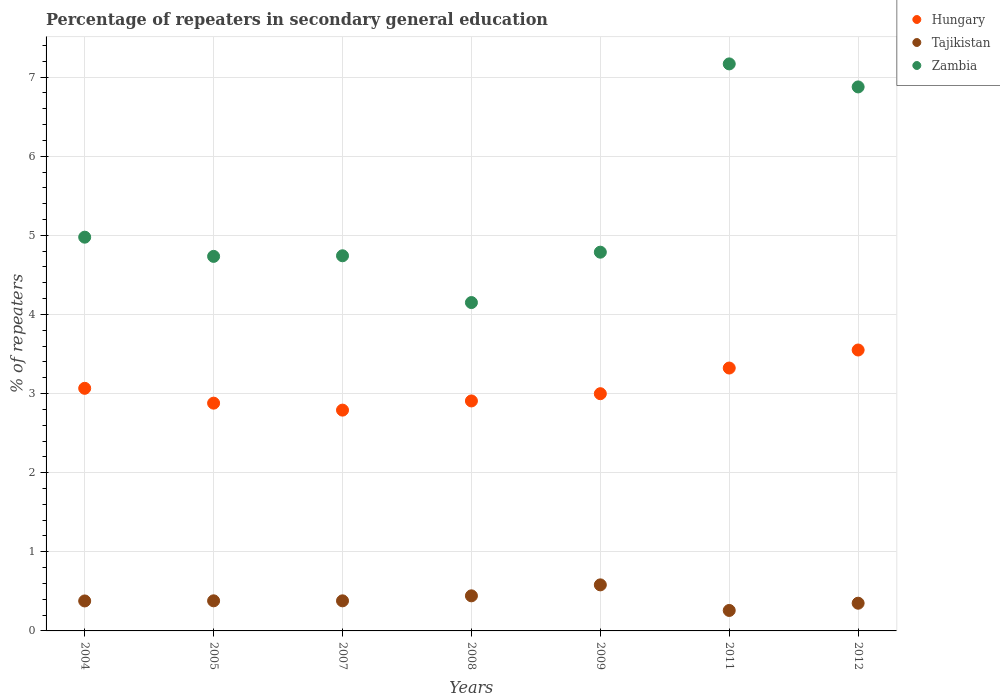How many different coloured dotlines are there?
Make the answer very short. 3. What is the percentage of repeaters in secondary general education in Zambia in 2004?
Your answer should be compact. 4.98. Across all years, what is the maximum percentage of repeaters in secondary general education in Hungary?
Offer a very short reply. 3.55. Across all years, what is the minimum percentage of repeaters in secondary general education in Tajikistan?
Ensure brevity in your answer.  0.26. In which year was the percentage of repeaters in secondary general education in Zambia maximum?
Make the answer very short. 2011. In which year was the percentage of repeaters in secondary general education in Hungary minimum?
Make the answer very short. 2007. What is the total percentage of repeaters in secondary general education in Tajikistan in the graph?
Make the answer very short. 2.77. What is the difference between the percentage of repeaters in secondary general education in Hungary in 2005 and that in 2011?
Make the answer very short. -0.44. What is the difference between the percentage of repeaters in secondary general education in Zambia in 2005 and the percentage of repeaters in secondary general education in Hungary in 2009?
Make the answer very short. 1.74. What is the average percentage of repeaters in secondary general education in Tajikistan per year?
Ensure brevity in your answer.  0.4. In the year 2007, what is the difference between the percentage of repeaters in secondary general education in Tajikistan and percentage of repeaters in secondary general education in Hungary?
Your answer should be very brief. -2.41. In how many years, is the percentage of repeaters in secondary general education in Hungary greater than 3.4 %?
Provide a succinct answer. 1. What is the ratio of the percentage of repeaters in secondary general education in Hungary in 2008 to that in 2009?
Offer a terse response. 0.97. What is the difference between the highest and the second highest percentage of repeaters in secondary general education in Zambia?
Your answer should be compact. 0.29. What is the difference between the highest and the lowest percentage of repeaters in secondary general education in Tajikistan?
Provide a succinct answer. 0.32. In how many years, is the percentage of repeaters in secondary general education in Hungary greater than the average percentage of repeaters in secondary general education in Hungary taken over all years?
Your response must be concise. 2. Does the percentage of repeaters in secondary general education in Zambia monotonically increase over the years?
Your answer should be very brief. No. How many years are there in the graph?
Make the answer very short. 7. How many legend labels are there?
Make the answer very short. 3. How are the legend labels stacked?
Your response must be concise. Vertical. What is the title of the graph?
Give a very brief answer. Percentage of repeaters in secondary general education. What is the label or title of the Y-axis?
Provide a short and direct response. % of repeaters. What is the % of repeaters of Hungary in 2004?
Give a very brief answer. 3.07. What is the % of repeaters in Tajikistan in 2004?
Your response must be concise. 0.38. What is the % of repeaters in Zambia in 2004?
Ensure brevity in your answer.  4.98. What is the % of repeaters of Hungary in 2005?
Offer a very short reply. 2.88. What is the % of repeaters in Tajikistan in 2005?
Give a very brief answer. 0.38. What is the % of repeaters of Zambia in 2005?
Offer a terse response. 4.73. What is the % of repeaters in Hungary in 2007?
Make the answer very short. 2.79. What is the % of repeaters in Tajikistan in 2007?
Give a very brief answer. 0.38. What is the % of repeaters in Zambia in 2007?
Ensure brevity in your answer.  4.74. What is the % of repeaters of Hungary in 2008?
Offer a terse response. 2.91. What is the % of repeaters of Tajikistan in 2008?
Ensure brevity in your answer.  0.44. What is the % of repeaters of Zambia in 2008?
Make the answer very short. 4.15. What is the % of repeaters in Hungary in 2009?
Make the answer very short. 3. What is the % of repeaters in Tajikistan in 2009?
Ensure brevity in your answer.  0.58. What is the % of repeaters of Zambia in 2009?
Provide a short and direct response. 4.79. What is the % of repeaters in Hungary in 2011?
Offer a very short reply. 3.32. What is the % of repeaters of Tajikistan in 2011?
Your response must be concise. 0.26. What is the % of repeaters in Zambia in 2011?
Keep it short and to the point. 7.17. What is the % of repeaters of Hungary in 2012?
Ensure brevity in your answer.  3.55. What is the % of repeaters of Tajikistan in 2012?
Make the answer very short. 0.35. What is the % of repeaters of Zambia in 2012?
Make the answer very short. 6.88. Across all years, what is the maximum % of repeaters in Hungary?
Offer a very short reply. 3.55. Across all years, what is the maximum % of repeaters of Tajikistan?
Provide a succinct answer. 0.58. Across all years, what is the maximum % of repeaters of Zambia?
Your response must be concise. 7.17. Across all years, what is the minimum % of repeaters of Hungary?
Make the answer very short. 2.79. Across all years, what is the minimum % of repeaters in Tajikistan?
Keep it short and to the point. 0.26. Across all years, what is the minimum % of repeaters of Zambia?
Your answer should be very brief. 4.15. What is the total % of repeaters in Hungary in the graph?
Your response must be concise. 21.51. What is the total % of repeaters of Tajikistan in the graph?
Provide a succinct answer. 2.77. What is the total % of repeaters in Zambia in the graph?
Your response must be concise. 37.43. What is the difference between the % of repeaters in Hungary in 2004 and that in 2005?
Offer a terse response. 0.19. What is the difference between the % of repeaters in Tajikistan in 2004 and that in 2005?
Your answer should be very brief. -0. What is the difference between the % of repeaters in Zambia in 2004 and that in 2005?
Make the answer very short. 0.24. What is the difference between the % of repeaters in Hungary in 2004 and that in 2007?
Keep it short and to the point. 0.28. What is the difference between the % of repeaters of Tajikistan in 2004 and that in 2007?
Your answer should be compact. -0. What is the difference between the % of repeaters in Zambia in 2004 and that in 2007?
Give a very brief answer. 0.24. What is the difference between the % of repeaters of Hungary in 2004 and that in 2008?
Provide a short and direct response. 0.16. What is the difference between the % of repeaters in Tajikistan in 2004 and that in 2008?
Offer a terse response. -0.06. What is the difference between the % of repeaters of Zambia in 2004 and that in 2008?
Ensure brevity in your answer.  0.83. What is the difference between the % of repeaters in Hungary in 2004 and that in 2009?
Ensure brevity in your answer.  0.07. What is the difference between the % of repeaters of Tajikistan in 2004 and that in 2009?
Offer a very short reply. -0.2. What is the difference between the % of repeaters in Zambia in 2004 and that in 2009?
Give a very brief answer. 0.19. What is the difference between the % of repeaters of Hungary in 2004 and that in 2011?
Ensure brevity in your answer.  -0.26. What is the difference between the % of repeaters of Tajikistan in 2004 and that in 2011?
Provide a succinct answer. 0.12. What is the difference between the % of repeaters of Zambia in 2004 and that in 2011?
Your answer should be very brief. -2.19. What is the difference between the % of repeaters of Hungary in 2004 and that in 2012?
Give a very brief answer. -0.48. What is the difference between the % of repeaters in Tajikistan in 2004 and that in 2012?
Give a very brief answer. 0.03. What is the difference between the % of repeaters of Zambia in 2004 and that in 2012?
Give a very brief answer. -1.9. What is the difference between the % of repeaters of Hungary in 2005 and that in 2007?
Provide a short and direct response. 0.09. What is the difference between the % of repeaters in Zambia in 2005 and that in 2007?
Offer a very short reply. -0.01. What is the difference between the % of repeaters in Hungary in 2005 and that in 2008?
Keep it short and to the point. -0.03. What is the difference between the % of repeaters in Tajikistan in 2005 and that in 2008?
Your answer should be very brief. -0.06. What is the difference between the % of repeaters of Zambia in 2005 and that in 2008?
Provide a short and direct response. 0.58. What is the difference between the % of repeaters of Hungary in 2005 and that in 2009?
Your response must be concise. -0.12. What is the difference between the % of repeaters of Tajikistan in 2005 and that in 2009?
Give a very brief answer. -0.2. What is the difference between the % of repeaters of Zambia in 2005 and that in 2009?
Your answer should be compact. -0.05. What is the difference between the % of repeaters of Hungary in 2005 and that in 2011?
Ensure brevity in your answer.  -0.44. What is the difference between the % of repeaters of Tajikistan in 2005 and that in 2011?
Give a very brief answer. 0.12. What is the difference between the % of repeaters of Zambia in 2005 and that in 2011?
Keep it short and to the point. -2.43. What is the difference between the % of repeaters in Hungary in 2005 and that in 2012?
Offer a terse response. -0.67. What is the difference between the % of repeaters in Tajikistan in 2005 and that in 2012?
Give a very brief answer. 0.03. What is the difference between the % of repeaters of Zambia in 2005 and that in 2012?
Make the answer very short. -2.14. What is the difference between the % of repeaters in Hungary in 2007 and that in 2008?
Provide a short and direct response. -0.12. What is the difference between the % of repeaters in Tajikistan in 2007 and that in 2008?
Keep it short and to the point. -0.06. What is the difference between the % of repeaters in Zambia in 2007 and that in 2008?
Ensure brevity in your answer.  0.59. What is the difference between the % of repeaters in Hungary in 2007 and that in 2009?
Your answer should be very brief. -0.21. What is the difference between the % of repeaters of Tajikistan in 2007 and that in 2009?
Your answer should be very brief. -0.2. What is the difference between the % of repeaters of Zambia in 2007 and that in 2009?
Ensure brevity in your answer.  -0.05. What is the difference between the % of repeaters in Hungary in 2007 and that in 2011?
Offer a terse response. -0.53. What is the difference between the % of repeaters of Tajikistan in 2007 and that in 2011?
Give a very brief answer. 0.12. What is the difference between the % of repeaters in Zambia in 2007 and that in 2011?
Give a very brief answer. -2.43. What is the difference between the % of repeaters in Hungary in 2007 and that in 2012?
Your response must be concise. -0.76. What is the difference between the % of repeaters in Zambia in 2007 and that in 2012?
Your answer should be very brief. -2.13. What is the difference between the % of repeaters of Hungary in 2008 and that in 2009?
Provide a short and direct response. -0.09. What is the difference between the % of repeaters of Tajikistan in 2008 and that in 2009?
Give a very brief answer. -0.14. What is the difference between the % of repeaters in Zambia in 2008 and that in 2009?
Make the answer very short. -0.64. What is the difference between the % of repeaters in Hungary in 2008 and that in 2011?
Keep it short and to the point. -0.42. What is the difference between the % of repeaters in Tajikistan in 2008 and that in 2011?
Give a very brief answer. 0.18. What is the difference between the % of repeaters of Zambia in 2008 and that in 2011?
Keep it short and to the point. -3.02. What is the difference between the % of repeaters of Hungary in 2008 and that in 2012?
Keep it short and to the point. -0.64. What is the difference between the % of repeaters in Tajikistan in 2008 and that in 2012?
Offer a terse response. 0.09. What is the difference between the % of repeaters of Zambia in 2008 and that in 2012?
Keep it short and to the point. -2.73. What is the difference between the % of repeaters of Hungary in 2009 and that in 2011?
Offer a terse response. -0.32. What is the difference between the % of repeaters in Tajikistan in 2009 and that in 2011?
Provide a succinct answer. 0.32. What is the difference between the % of repeaters of Zambia in 2009 and that in 2011?
Your answer should be very brief. -2.38. What is the difference between the % of repeaters in Hungary in 2009 and that in 2012?
Ensure brevity in your answer.  -0.55. What is the difference between the % of repeaters in Tajikistan in 2009 and that in 2012?
Your answer should be compact. 0.23. What is the difference between the % of repeaters in Zambia in 2009 and that in 2012?
Offer a very short reply. -2.09. What is the difference between the % of repeaters of Hungary in 2011 and that in 2012?
Provide a short and direct response. -0.23. What is the difference between the % of repeaters in Tajikistan in 2011 and that in 2012?
Ensure brevity in your answer.  -0.09. What is the difference between the % of repeaters of Zambia in 2011 and that in 2012?
Your answer should be compact. 0.29. What is the difference between the % of repeaters in Hungary in 2004 and the % of repeaters in Tajikistan in 2005?
Your answer should be very brief. 2.69. What is the difference between the % of repeaters of Hungary in 2004 and the % of repeaters of Zambia in 2005?
Your response must be concise. -1.67. What is the difference between the % of repeaters in Tajikistan in 2004 and the % of repeaters in Zambia in 2005?
Your response must be concise. -4.35. What is the difference between the % of repeaters of Hungary in 2004 and the % of repeaters of Tajikistan in 2007?
Give a very brief answer. 2.69. What is the difference between the % of repeaters of Hungary in 2004 and the % of repeaters of Zambia in 2007?
Your answer should be very brief. -1.68. What is the difference between the % of repeaters in Tajikistan in 2004 and the % of repeaters in Zambia in 2007?
Ensure brevity in your answer.  -4.36. What is the difference between the % of repeaters in Hungary in 2004 and the % of repeaters in Tajikistan in 2008?
Your answer should be very brief. 2.62. What is the difference between the % of repeaters of Hungary in 2004 and the % of repeaters of Zambia in 2008?
Offer a very short reply. -1.08. What is the difference between the % of repeaters in Tajikistan in 2004 and the % of repeaters in Zambia in 2008?
Your answer should be very brief. -3.77. What is the difference between the % of repeaters in Hungary in 2004 and the % of repeaters in Tajikistan in 2009?
Your answer should be compact. 2.48. What is the difference between the % of repeaters in Hungary in 2004 and the % of repeaters in Zambia in 2009?
Provide a short and direct response. -1.72. What is the difference between the % of repeaters of Tajikistan in 2004 and the % of repeaters of Zambia in 2009?
Your answer should be very brief. -4.41. What is the difference between the % of repeaters of Hungary in 2004 and the % of repeaters of Tajikistan in 2011?
Your answer should be very brief. 2.81. What is the difference between the % of repeaters of Hungary in 2004 and the % of repeaters of Zambia in 2011?
Your answer should be very brief. -4.1. What is the difference between the % of repeaters in Tajikistan in 2004 and the % of repeaters in Zambia in 2011?
Offer a terse response. -6.79. What is the difference between the % of repeaters in Hungary in 2004 and the % of repeaters in Tajikistan in 2012?
Your answer should be compact. 2.72. What is the difference between the % of repeaters of Hungary in 2004 and the % of repeaters of Zambia in 2012?
Your answer should be very brief. -3.81. What is the difference between the % of repeaters of Tajikistan in 2004 and the % of repeaters of Zambia in 2012?
Make the answer very short. -6.5. What is the difference between the % of repeaters in Hungary in 2005 and the % of repeaters in Tajikistan in 2007?
Provide a short and direct response. 2.5. What is the difference between the % of repeaters of Hungary in 2005 and the % of repeaters of Zambia in 2007?
Provide a succinct answer. -1.86. What is the difference between the % of repeaters of Tajikistan in 2005 and the % of repeaters of Zambia in 2007?
Your response must be concise. -4.36. What is the difference between the % of repeaters of Hungary in 2005 and the % of repeaters of Tajikistan in 2008?
Ensure brevity in your answer.  2.44. What is the difference between the % of repeaters of Hungary in 2005 and the % of repeaters of Zambia in 2008?
Provide a short and direct response. -1.27. What is the difference between the % of repeaters in Tajikistan in 2005 and the % of repeaters in Zambia in 2008?
Give a very brief answer. -3.77. What is the difference between the % of repeaters of Hungary in 2005 and the % of repeaters of Tajikistan in 2009?
Your response must be concise. 2.3. What is the difference between the % of repeaters in Hungary in 2005 and the % of repeaters in Zambia in 2009?
Your response must be concise. -1.91. What is the difference between the % of repeaters in Tajikistan in 2005 and the % of repeaters in Zambia in 2009?
Keep it short and to the point. -4.41. What is the difference between the % of repeaters of Hungary in 2005 and the % of repeaters of Tajikistan in 2011?
Your answer should be compact. 2.62. What is the difference between the % of repeaters in Hungary in 2005 and the % of repeaters in Zambia in 2011?
Your answer should be compact. -4.29. What is the difference between the % of repeaters in Tajikistan in 2005 and the % of repeaters in Zambia in 2011?
Make the answer very short. -6.79. What is the difference between the % of repeaters in Hungary in 2005 and the % of repeaters in Tajikistan in 2012?
Your answer should be very brief. 2.53. What is the difference between the % of repeaters in Hungary in 2005 and the % of repeaters in Zambia in 2012?
Keep it short and to the point. -4. What is the difference between the % of repeaters of Tajikistan in 2005 and the % of repeaters of Zambia in 2012?
Your response must be concise. -6.5. What is the difference between the % of repeaters in Hungary in 2007 and the % of repeaters in Tajikistan in 2008?
Offer a terse response. 2.35. What is the difference between the % of repeaters in Hungary in 2007 and the % of repeaters in Zambia in 2008?
Your response must be concise. -1.36. What is the difference between the % of repeaters of Tajikistan in 2007 and the % of repeaters of Zambia in 2008?
Provide a succinct answer. -3.77. What is the difference between the % of repeaters of Hungary in 2007 and the % of repeaters of Tajikistan in 2009?
Your answer should be very brief. 2.21. What is the difference between the % of repeaters of Hungary in 2007 and the % of repeaters of Zambia in 2009?
Your response must be concise. -2. What is the difference between the % of repeaters of Tajikistan in 2007 and the % of repeaters of Zambia in 2009?
Keep it short and to the point. -4.41. What is the difference between the % of repeaters of Hungary in 2007 and the % of repeaters of Tajikistan in 2011?
Offer a very short reply. 2.53. What is the difference between the % of repeaters of Hungary in 2007 and the % of repeaters of Zambia in 2011?
Make the answer very short. -4.38. What is the difference between the % of repeaters in Tajikistan in 2007 and the % of repeaters in Zambia in 2011?
Provide a succinct answer. -6.79. What is the difference between the % of repeaters in Hungary in 2007 and the % of repeaters in Tajikistan in 2012?
Offer a terse response. 2.44. What is the difference between the % of repeaters of Hungary in 2007 and the % of repeaters of Zambia in 2012?
Ensure brevity in your answer.  -4.08. What is the difference between the % of repeaters in Tajikistan in 2007 and the % of repeaters in Zambia in 2012?
Your response must be concise. -6.5. What is the difference between the % of repeaters in Hungary in 2008 and the % of repeaters in Tajikistan in 2009?
Keep it short and to the point. 2.32. What is the difference between the % of repeaters in Hungary in 2008 and the % of repeaters in Zambia in 2009?
Give a very brief answer. -1.88. What is the difference between the % of repeaters in Tajikistan in 2008 and the % of repeaters in Zambia in 2009?
Give a very brief answer. -4.34. What is the difference between the % of repeaters of Hungary in 2008 and the % of repeaters of Tajikistan in 2011?
Offer a terse response. 2.65. What is the difference between the % of repeaters of Hungary in 2008 and the % of repeaters of Zambia in 2011?
Offer a terse response. -4.26. What is the difference between the % of repeaters in Tajikistan in 2008 and the % of repeaters in Zambia in 2011?
Provide a succinct answer. -6.72. What is the difference between the % of repeaters in Hungary in 2008 and the % of repeaters in Tajikistan in 2012?
Give a very brief answer. 2.56. What is the difference between the % of repeaters of Hungary in 2008 and the % of repeaters of Zambia in 2012?
Your answer should be very brief. -3.97. What is the difference between the % of repeaters in Tajikistan in 2008 and the % of repeaters in Zambia in 2012?
Your response must be concise. -6.43. What is the difference between the % of repeaters in Hungary in 2009 and the % of repeaters in Tajikistan in 2011?
Make the answer very short. 2.74. What is the difference between the % of repeaters in Hungary in 2009 and the % of repeaters in Zambia in 2011?
Make the answer very short. -4.17. What is the difference between the % of repeaters in Tajikistan in 2009 and the % of repeaters in Zambia in 2011?
Provide a short and direct response. -6.58. What is the difference between the % of repeaters of Hungary in 2009 and the % of repeaters of Tajikistan in 2012?
Your answer should be very brief. 2.65. What is the difference between the % of repeaters of Hungary in 2009 and the % of repeaters of Zambia in 2012?
Make the answer very short. -3.88. What is the difference between the % of repeaters in Tajikistan in 2009 and the % of repeaters in Zambia in 2012?
Give a very brief answer. -6.29. What is the difference between the % of repeaters in Hungary in 2011 and the % of repeaters in Tajikistan in 2012?
Offer a terse response. 2.97. What is the difference between the % of repeaters in Hungary in 2011 and the % of repeaters in Zambia in 2012?
Your answer should be very brief. -3.55. What is the difference between the % of repeaters in Tajikistan in 2011 and the % of repeaters in Zambia in 2012?
Make the answer very short. -6.62. What is the average % of repeaters in Hungary per year?
Give a very brief answer. 3.07. What is the average % of repeaters in Tajikistan per year?
Keep it short and to the point. 0.4. What is the average % of repeaters in Zambia per year?
Provide a short and direct response. 5.35. In the year 2004, what is the difference between the % of repeaters in Hungary and % of repeaters in Tajikistan?
Give a very brief answer. 2.69. In the year 2004, what is the difference between the % of repeaters in Hungary and % of repeaters in Zambia?
Ensure brevity in your answer.  -1.91. In the year 2004, what is the difference between the % of repeaters of Tajikistan and % of repeaters of Zambia?
Offer a very short reply. -4.6. In the year 2005, what is the difference between the % of repeaters of Hungary and % of repeaters of Tajikistan?
Your answer should be compact. 2.5. In the year 2005, what is the difference between the % of repeaters of Hungary and % of repeaters of Zambia?
Keep it short and to the point. -1.85. In the year 2005, what is the difference between the % of repeaters of Tajikistan and % of repeaters of Zambia?
Offer a terse response. -4.35. In the year 2007, what is the difference between the % of repeaters in Hungary and % of repeaters in Tajikistan?
Your answer should be compact. 2.41. In the year 2007, what is the difference between the % of repeaters in Hungary and % of repeaters in Zambia?
Ensure brevity in your answer.  -1.95. In the year 2007, what is the difference between the % of repeaters in Tajikistan and % of repeaters in Zambia?
Offer a very short reply. -4.36. In the year 2008, what is the difference between the % of repeaters in Hungary and % of repeaters in Tajikistan?
Keep it short and to the point. 2.46. In the year 2008, what is the difference between the % of repeaters in Hungary and % of repeaters in Zambia?
Offer a terse response. -1.24. In the year 2008, what is the difference between the % of repeaters in Tajikistan and % of repeaters in Zambia?
Keep it short and to the point. -3.71. In the year 2009, what is the difference between the % of repeaters of Hungary and % of repeaters of Tajikistan?
Provide a succinct answer. 2.42. In the year 2009, what is the difference between the % of repeaters of Hungary and % of repeaters of Zambia?
Provide a succinct answer. -1.79. In the year 2009, what is the difference between the % of repeaters in Tajikistan and % of repeaters in Zambia?
Your answer should be compact. -4.2. In the year 2011, what is the difference between the % of repeaters of Hungary and % of repeaters of Tajikistan?
Ensure brevity in your answer.  3.06. In the year 2011, what is the difference between the % of repeaters in Hungary and % of repeaters in Zambia?
Ensure brevity in your answer.  -3.84. In the year 2011, what is the difference between the % of repeaters of Tajikistan and % of repeaters of Zambia?
Provide a short and direct response. -6.91. In the year 2012, what is the difference between the % of repeaters of Hungary and % of repeaters of Tajikistan?
Ensure brevity in your answer.  3.2. In the year 2012, what is the difference between the % of repeaters in Hungary and % of repeaters in Zambia?
Give a very brief answer. -3.33. In the year 2012, what is the difference between the % of repeaters in Tajikistan and % of repeaters in Zambia?
Keep it short and to the point. -6.53. What is the ratio of the % of repeaters of Hungary in 2004 to that in 2005?
Provide a succinct answer. 1.07. What is the ratio of the % of repeaters in Tajikistan in 2004 to that in 2005?
Your answer should be compact. 1. What is the ratio of the % of repeaters of Zambia in 2004 to that in 2005?
Your answer should be compact. 1.05. What is the ratio of the % of repeaters in Hungary in 2004 to that in 2007?
Keep it short and to the point. 1.1. What is the ratio of the % of repeaters in Zambia in 2004 to that in 2007?
Keep it short and to the point. 1.05. What is the ratio of the % of repeaters in Hungary in 2004 to that in 2008?
Ensure brevity in your answer.  1.05. What is the ratio of the % of repeaters of Tajikistan in 2004 to that in 2008?
Your response must be concise. 0.85. What is the ratio of the % of repeaters of Zambia in 2004 to that in 2008?
Offer a very short reply. 1.2. What is the ratio of the % of repeaters in Hungary in 2004 to that in 2009?
Offer a terse response. 1.02. What is the ratio of the % of repeaters of Tajikistan in 2004 to that in 2009?
Ensure brevity in your answer.  0.65. What is the ratio of the % of repeaters of Zambia in 2004 to that in 2009?
Offer a terse response. 1.04. What is the ratio of the % of repeaters of Hungary in 2004 to that in 2011?
Provide a short and direct response. 0.92. What is the ratio of the % of repeaters of Tajikistan in 2004 to that in 2011?
Keep it short and to the point. 1.46. What is the ratio of the % of repeaters in Zambia in 2004 to that in 2011?
Your answer should be very brief. 0.69. What is the ratio of the % of repeaters of Hungary in 2004 to that in 2012?
Provide a short and direct response. 0.86. What is the ratio of the % of repeaters of Tajikistan in 2004 to that in 2012?
Keep it short and to the point. 1.08. What is the ratio of the % of repeaters in Zambia in 2004 to that in 2012?
Give a very brief answer. 0.72. What is the ratio of the % of repeaters of Hungary in 2005 to that in 2007?
Provide a succinct answer. 1.03. What is the ratio of the % of repeaters of Tajikistan in 2005 to that in 2007?
Offer a terse response. 1. What is the ratio of the % of repeaters in Zambia in 2005 to that in 2007?
Provide a succinct answer. 1. What is the ratio of the % of repeaters in Hungary in 2005 to that in 2008?
Your answer should be very brief. 0.99. What is the ratio of the % of repeaters of Tajikistan in 2005 to that in 2008?
Make the answer very short. 0.86. What is the ratio of the % of repeaters in Zambia in 2005 to that in 2008?
Give a very brief answer. 1.14. What is the ratio of the % of repeaters in Hungary in 2005 to that in 2009?
Provide a short and direct response. 0.96. What is the ratio of the % of repeaters in Tajikistan in 2005 to that in 2009?
Your answer should be compact. 0.65. What is the ratio of the % of repeaters in Zambia in 2005 to that in 2009?
Provide a short and direct response. 0.99. What is the ratio of the % of repeaters in Hungary in 2005 to that in 2011?
Provide a succinct answer. 0.87. What is the ratio of the % of repeaters in Tajikistan in 2005 to that in 2011?
Offer a terse response. 1.47. What is the ratio of the % of repeaters of Zambia in 2005 to that in 2011?
Your answer should be compact. 0.66. What is the ratio of the % of repeaters of Hungary in 2005 to that in 2012?
Provide a succinct answer. 0.81. What is the ratio of the % of repeaters of Tajikistan in 2005 to that in 2012?
Offer a very short reply. 1.09. What is the ratio of the % of repeaters in Zambia in 2005 to that in 2012?
Offer a very short reply. 0.69. What is the ratio of the % of repeaters in Hungary in 2007 to that in 2008?
Provide a short and direct response. 0.96. What is the ratio of the % of repeaters in Tajikistan in 2007 to that in 2008?
Give a very brief answer. 0.86. What is the ratio of the % of repeaters in Zambia in 2007 to that in 2008?
Offer a terse response. 1.14. What is the ratio of the % of repeaters of Hungary in 2007 to that in 2009?
Keep it short and to the point. 0.93. What is the ratio of the % of repeaters of Tajikistan in 2007 to that in 2009?
Ensure brevity in your answer.  0.65. What is the ratio of the % of repeaters of Zambia in 2007 to that in 2009?
Give a very brief answer. 0.99. What is the ratio of the % of repeaters in Hungary in 2007 to that in 2011?
Your response must be concise. 0.84. What is the ratio of the % of repeaters in Tajikistan in 2007 to that in 2011?
Offer a terse response. 1.47. What is the ratio of the % of repeaters in Zambia in 2007 to that in 2011?
Offer a terse response. 0.66. What is the ratio of the % of repeaters in Hungary in 2007 to that in 2012?
Make the answer very short. 0.79. What is the ratio of the % of repeaters of Tajikistan in 2007 to that in 2012?
Give a very brief answer. 1.09. What is the ratio of the % of repeaters in Zambia in 2007 to that in 2012?
Provide a short and direct response. 0.69. What is the ratio of the % of repeaters in Hungary in 2008 to that in 2009?
Your response must be concise. 0.97. What is the ratio of the % of repeaters in Tajikistan in 2008 to that in 2009?
Your response must be concise. 0.76. What is the ratio of the % of repeaters in Zambia in 2008 to that in 2009?
Make the answer very short. 0.87. What is the ratio of the % of repeaters of Hungary in 2008 to that in 2011?
Ensure brevity in your answer.  0.87. What is the ratio of the % of repeaters in Tajikistan in 2008 to that in 2011?
Provide a short and direct response. 1.71. What is the ratio of the % of repeaters in Zambia in 2008 to that in 2011?
Make the answer very short. 0.58. What is the ratio of the % of repeaters of Hungary in 2008 to that in 2012?
Keep it short and to the point. 0.82. What is the ratio of the % of repeaters of Tajikistan in 2008 to that in 2012?
Offer a very short reply. 1.27. What is the ratio of the % of repeaters in Zambia in 2008 to that in 2012?
Your response must be concise. 0.6. What is the ratio of the % of repeaters of Hungary in 2009 to that in 2011?
Give a very brief answer. 0.9. What is the ratio of the % of repeaters in Tajikistan in 2009 to that in 2011?
Your response must be concise. 2.25. What is the ratio of the % of repeaters of Zambia in 2009 to that in 2011?
Make the answer very short. 0.67. What is the ratio of the % of repeaters in Hungary in 2009 to that in 2012?
Provide a succinct answer. 0.84. What is the ratio of the % of repeaters of Tajikistan in 2009 to that in 2012?
Offer a terse response. 1.66. What is the ratio of the % of repeaters of Zambia in 2009 to that in 2012?
Ensure brevity in your answer.  0.7. What is the ratio of the % of repeaters of Hungary in 2011 to that in 2012?
Keep it short and to the point. 0.94. What is the ratio of the % of repeaters in Tajikistan in 2011 to that in 2012?
Provide a short and direct response. 0.74. What is the ratio of the % of repeaters in Zambia in 2011 to that in 2012?
Give a very brief answer. 1.04. What is the difference between the highest and the second highest % of repeaters of Hungary?
Keep it short and to the point. 0.23. What is the difference between the highest and the second highest % of repeaters in Tajikistan?
Provide a succinct answer. 0.14. What is the difference between the highest and the second highest % of repeaters in Zambia?
Your answer should be compact. 0.29. What is the difference between the highest and the lowest % of repeaters in Hungary?
Ensure brevity in your answer.  0.76. What is the difference between the highest and the lowest % of repeaters of Tajikistan?
Your answer should be very brief. 0.32. What is the difference between the highest and the lowest % of repeaters of Zambia?
Provide a short and direct response. 3.02. 